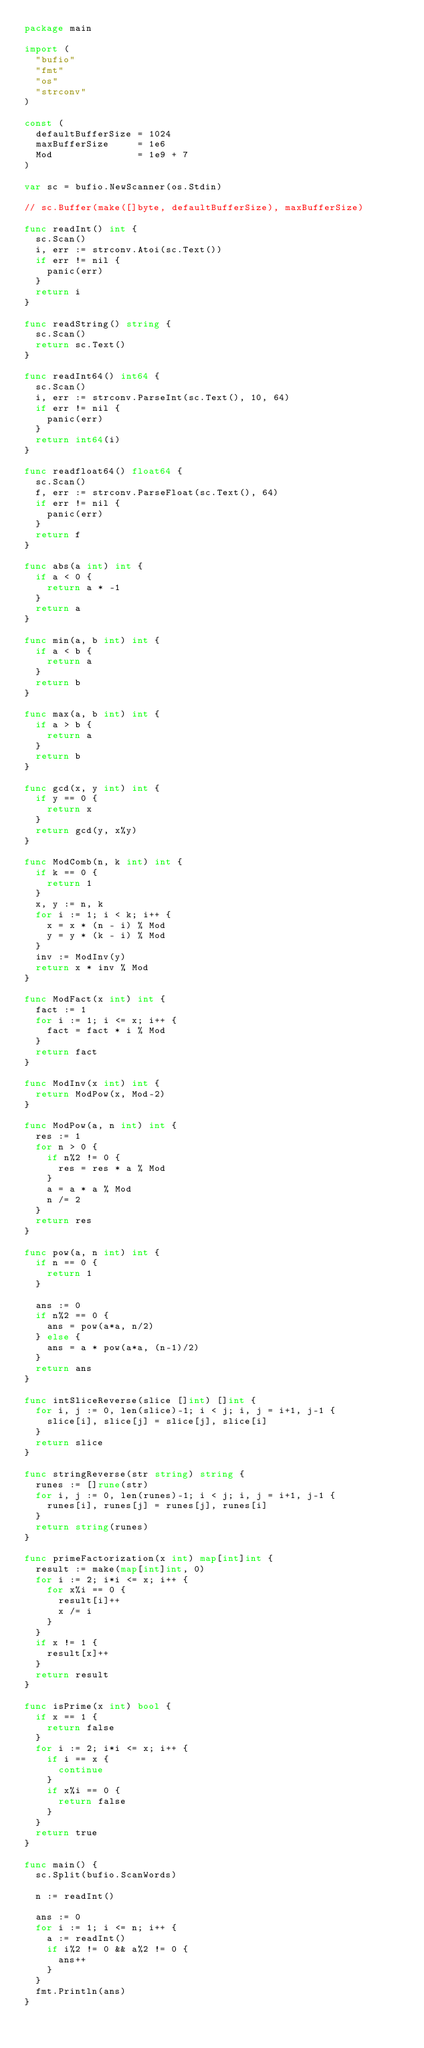Convert code to text. <code><loc_0><loc_0><loc_500><loc_500><_Go_>package main

import (
	"bufio"
	"fmt"
	"os"
	"strconv"
)

const (
	defaultBufferSize = 1024
	maxBufferSize     = 1e6
	Mod               = 1e9 + 7
)

var sc = bufio.NewScanner(os.Stdin)

// sc.Buffer(make([]byte, defaultBufferSize), maxBufferSize)

func readInt() int {
	sc.Scan()
	i, err := strconv.Atoi(sc.Text())
	if err != nil {
		panic(err)
	}
	return i
}

func readString() string {
	sc.Scan()
	return sc.Text()
}

func readInt64() int64 {
	sc.Scan()
	i, err := strconv.ParseInt(sc.Text(), 10, 64)
	if err != nil {
		panic(err)
	}
	return int64(i)
}

func readfloat64() float64 {
	sc.Scan()
	f, err := strconv.ParseFloat(sc.Text(), 64)
	if err != nil {
		panic(err)
	}
	return f
}

func abs(a int) int {
	if a < 0 {
		return a * -1
	}
	return a
}

func min(a, b int) int {
	if a < b {
		return a
	}
	return b
}

func max(a, b int) int {
	if a > b {
		return a
	}
	return b
}

func gcd(x, y int) int {
	if y == 0 {
		return x
	}
	return gcd(y, x%y)
}

func ModComb(n, k int) int {
	if k == 0 {
		return 1
	}
	x, y := n, k
	for i := 1; i < k; i++ {
		x = x * (n - i) % Mod
		y = y * (k - i) % Mod
	}
	inv := ModInv(y)
	return x * inv % Mod
}

func ModFact(x int) int {
	fact := 1
	for i := 1; i <= x; i++ {
		fact = fact * i % Mod
	}
	return fact
}

func ModInv(x int) int {
	return ModPow(x, Mod-2)
}

func ModPow(a, n int) int {
	res := 1
	for n > 0 {
		if n%2 != 0 {
			res = res * a % Mod
		}
		a = a * a % Mod
		n /= 2
	}
	return res
}

func pow(a, n int) int {
	if n == 0 {
		return 1
	}

	ans := 0
	if n%2 == 0 {
		ans = pow(a*a, n/2)
	} else {
		ans = a * pow(a*a, (n-1)/2)
	}
	return ans
}

func intSliceReverse(slice []int) []int {
	for i, j := 0, len(slice)-1; i < j; i, j = i+1, j-1 {
		slice[i], slice[j] = slice[j], slice[i]
	}
	return slice
}

func stringReverse(str string) string {
	runes := []rune(str)
	for i, j := 0, len(runes)-1; i < j; i, j = i+1, j-1 {
		runes[i], runes[j] = runes[j], runes[i]
	}
	return string(runes)
}

func primeFactorization(x int) map[int]int {
	result := make(map[int]int, 0)
	for i := 2; i*i <= x; i++ {
		for x%i == 0 {
			result[i]++
			x /= i
		}
	}
	if x != 1 {
		result[x]++
	}
	return result
}

func isPrime(x int) bool {
	if x == 1 {
		return false
	}
	for i := 2; i*i <= x; i++ {
		if i == x {
			continue
		}
		if x%i == 0 {
			return false
		}
	}
	return true
}

func main() {
	sc.Split(bufio.ScanWords)

	n := readInt()

	ans := 0
	for i := 1; i <= n; i++ {
		a := readInt()
		if i%2 != 0 && a%2 != 0 {
			ans++
		}
	}
	fmt.Println(ans)
}
</code> 